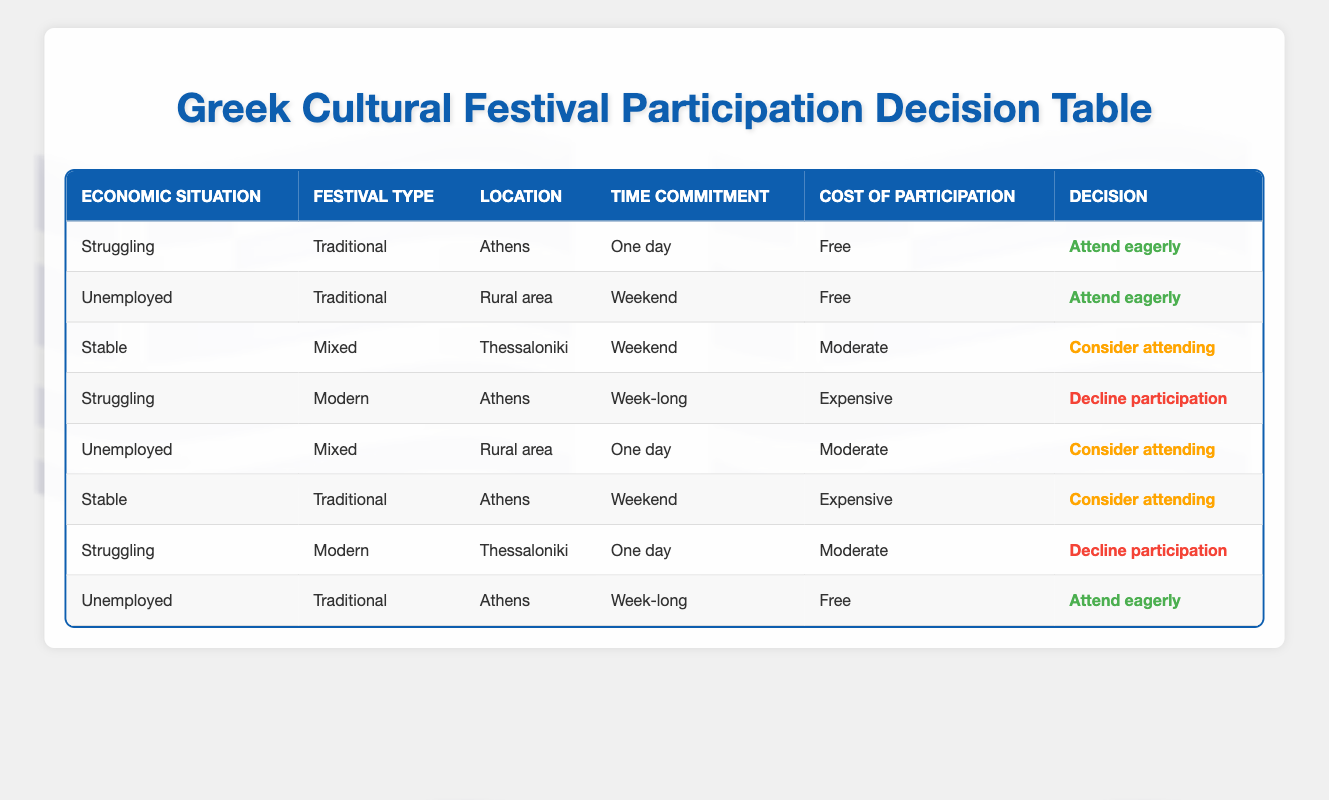What is the decision when the economic situation is "Struggling," festival type is "Traditional," location is "Athens," time commitment is "One day," and cost of participation is "Free"? According to the table, this specific combination is listed in one of the rows, where the conclusion is to "Attend eagerly."
Answer: Attend eagerly How many different decisions result in "Decline participation"? The table has two rows with the action "Decline participation." These occur when the economic situation is "Struggling" and the festival types are "Modern" in Athens and "Traditional" in Thessaloniki.
Answer: 2 Is there any scenario in which an "Unemployed" person will "Attend eagerly"? Yes, there are two cases in the table where "Unemployed" individuals "Attend eagerly": one is for a "Traditional" festival in a "Rural area" over a "Weekend" for "Free," and another is for a "Traditional" festival in "Athens" for a "Week-long" event that is "Free."
Answer: Yes What is the most common festival type for those who demonstrate a decision to "Consider attending"? By reviewing the rows with the action "Consider attending," we see the festival types are "Mixed" and "Traditional." The common type leading to "Consider attending" includes "Mixed" in one scenario and "Traditional" in two scenarios, making "Traditional" the most common festival type for this decision.
Answer: Traditional If the cost of participation is "Moderate," how many unique locations are involved in the decision to "Consider attending"? There are two instances in the table where a "Moderate" cost leads to a decision of "Consider attending." These occur in "Thessaloniki" and "Rural area." Thus, there are two unique locations tied to this outcome.
Answer: 2 What should a stable person expect if they want to attend a festival for a week in Athens? The table indicates that if a stable person is considering attending a festival for a week in Athens, there is no corresponding entry since the conditions do not align with the stipulated parameters of the table. Therefore, they should expect not to attend.
Answer: Not applicable How many different combinations lead to attending a traditional festival? Looking through the table, we find three distinct scenarios leading to "Attend eagerly" for a traditional festival: The first is for "Unemployed" in a "Rural area" during a "Weekend" for "Free," the second is "Struggling" in "Athens" "One day" for "Free," and the third is "Unemployed" in "Athens" during a "Week-long" for "Free." Thus, the total distinct combinations is three.
Answer: 3 What is the least favorable decision for someone in a "Struggling" economic situation? The table shows "Decline participation" occurs twice for "Struggling" individuals, specifically for "Modern" festivals in both locations of "Athens" and "Thessaloniki." This indicates that "Decline participation" is their least favorable decision under the most challenging conditions.
Answer: Decline participation In which location does a moderate cost lead to a decision of "Consider attending"? The cost of participation being "Moderate" leads to a decision of "Consider attending" predominantly in "Thessaloniki." This aligns with the specific conditions of stable economic situations and festival types that permit this action.
Answer: Thessaloniki 